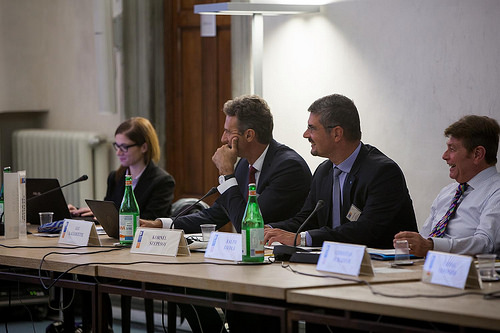<image>
Can you confirm if the bottle is in front of the man? Yes. The bottle is positioned in front of the man, appearing closer to the camera viewpoint. 